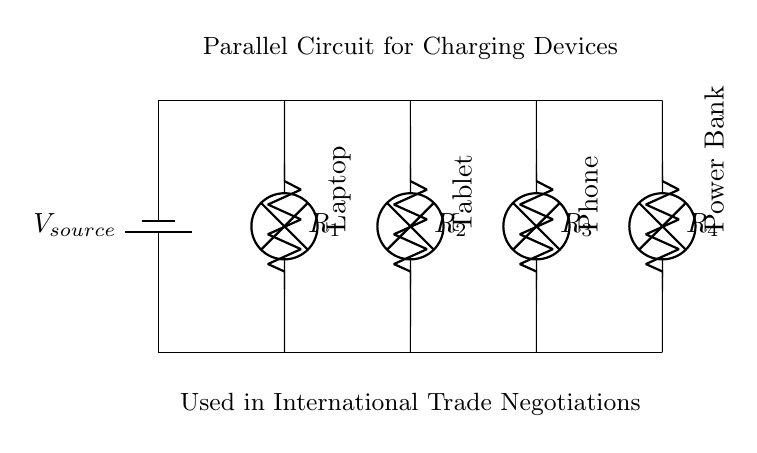What type of circuit is depicted? The circuit is a parallel circuit as indicated by the multiple paths for current to flow through various devices.
Answer: Parallel circuit How many devices are being charged in the circuit? There are four devices drawn in the circuit: a laptop, a tablet, a phone, and a power bank. Each is represented with a separate branch, typical of a parallel configuration.
Answer: Four devices What is the role of the resistors in this circuit? The resistors serve to limit the current flowing to each device. This is common practice in parallel circuits where devices can draw different amounts of current because they are connected across the same voltage source.
Answer: Limit current What is the voltage across each device? In a parallel circuit, the voltage across each of the devices is equal to the voltage of the source, which is indicated to be the same across all branches.
Answer: Voltage of source If one device is removed, what happens to the other devices? In a parallel circuit, if one device is removed, the other devices continue to operate normally as each has its own independent path to the voltage source. This characteristic defines the reliability of parallel circuits in practical applications.
Answer: Other devices continue What would happen if the resistance values were equal? If all resistance values were the same, this would lead to equal current distribution among the devices, making analysis straightforward. The current flowing through each device would be determined by the same formula, V/R, given V, the voltage, remains constant across all branches.
Answer: Equal current distribution 